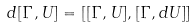<formula> <loc_0><loc_0><loc_500><loc_500>d [ \Gamma , U ] = [ [ \Gamma , U ] , [ \Gamma , d U ] ]</formula> 